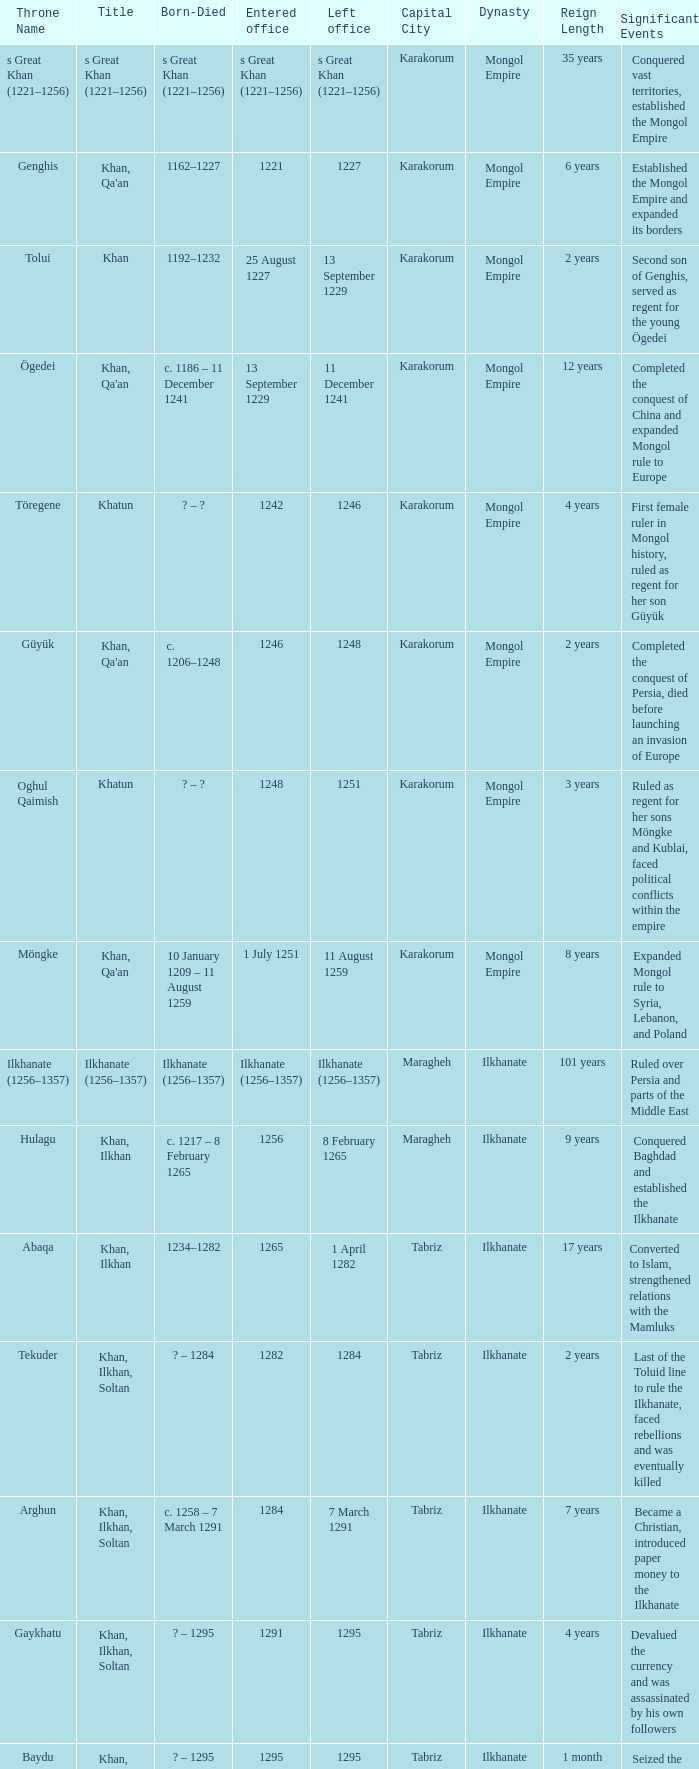What is the born-died that has office of 13 September 1229 as the entered? C. 1186 – 11 december 1241. 